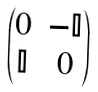Convert formula to latex. <formula><loc_0><loc_0><loc_500><loc_500>\begin{pmatrix} 0 & - \mathbb { I } \\ \mathbb { I } & 0 \end{pmatrix}</formula> 